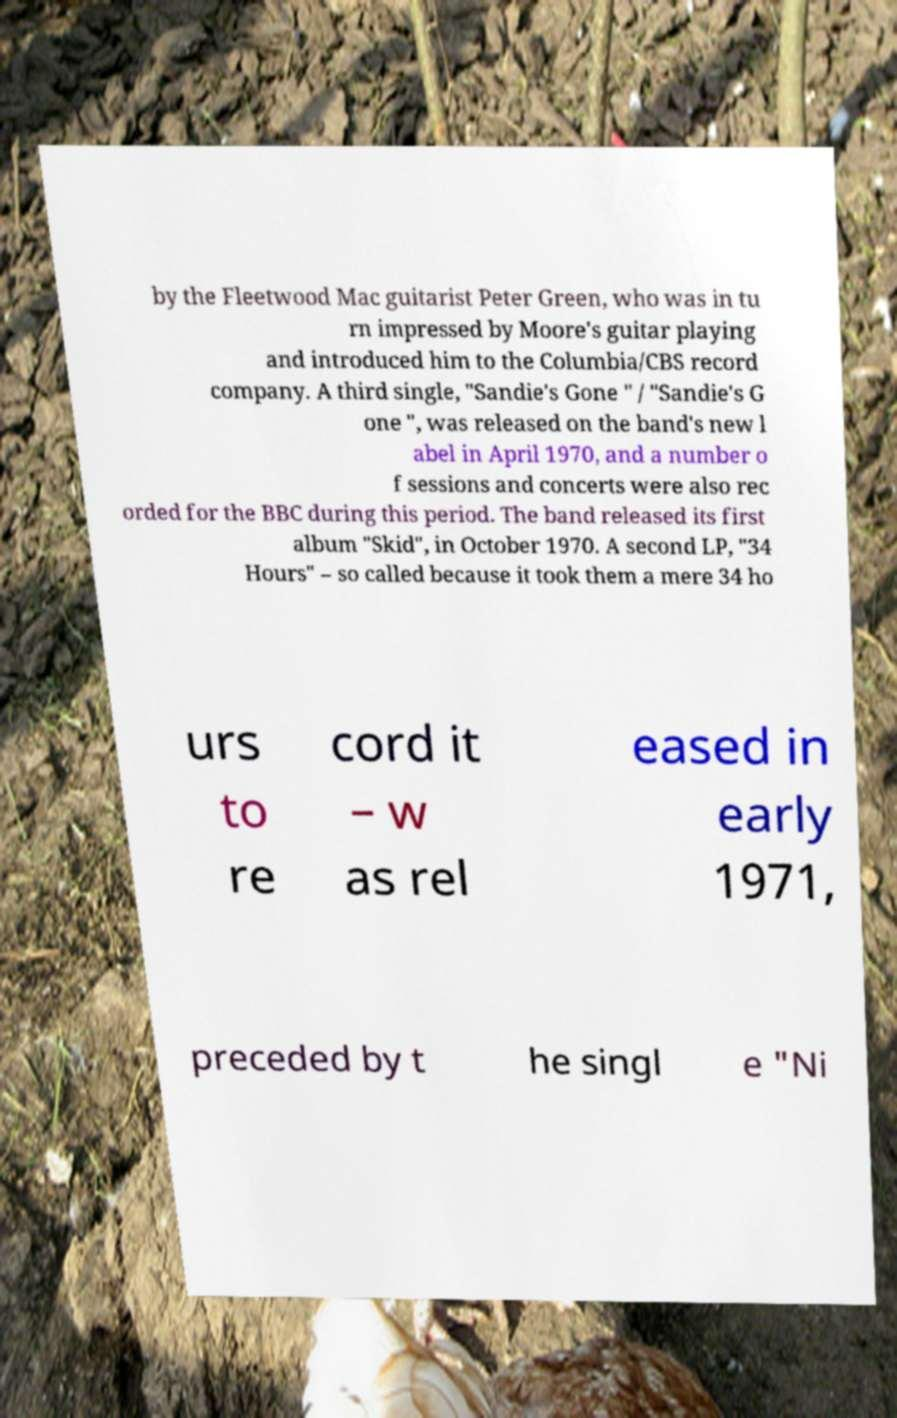What messages or text are displayed in this image? I need them in a readable, typed format. by the Fleetwood Mac guitarist Peter Green, who was in tu rn impressed by Moore's guitar playing and introduced him to the Columbia/CBS record company. A third single, "Sandie's Gone " / "Sandie's G one ", was released on the band's new l abel in April 1970, and a number o f sessions and concerts were also rec orded for the BBC during this period. The band released its first album "Skid", in October 1970. A second LP, "34 Hours" – so called because it took them a mere 34 ho urs to re cord it – w as rel eased in early 1971, preceded by t he singl e "Ni 